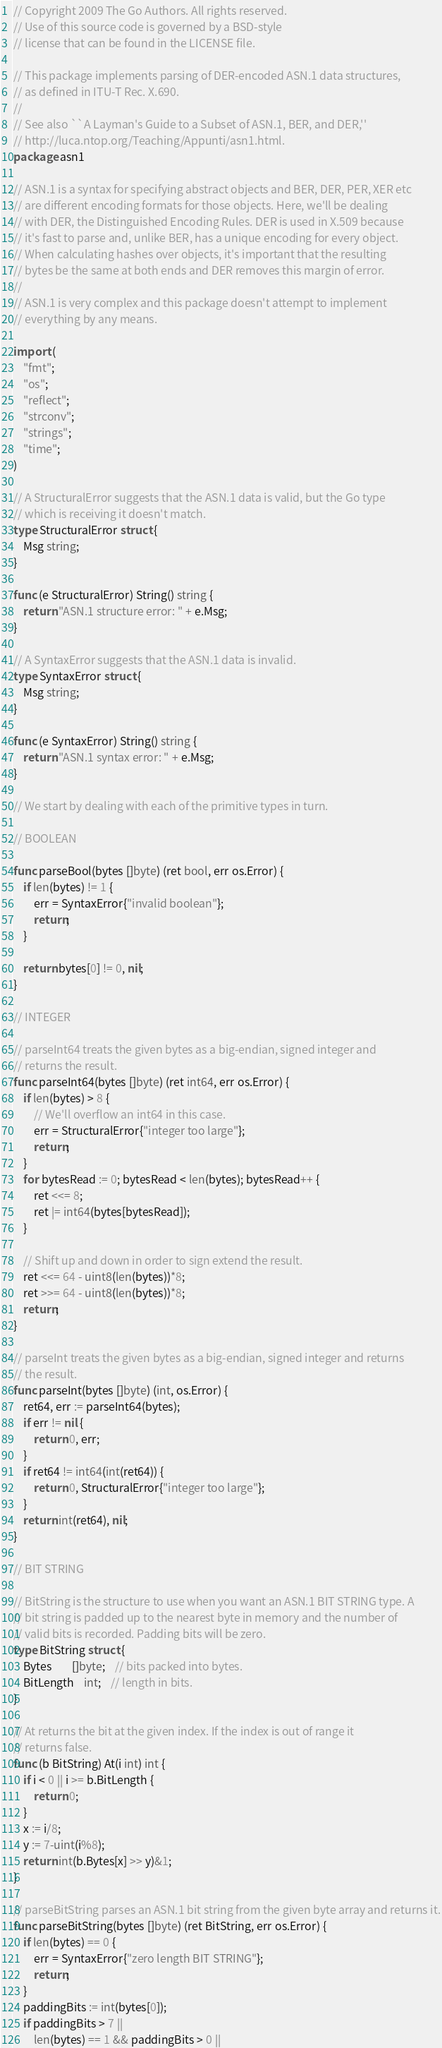Convert code to text. <code><loc_0><loc_0><loc_500><loc_500><_Go_>// Copyright 2009 The Go Authors. All rights reserved.
// Use of this source code is governed by a BSD-style
// license that can be found in the LICENSE file.

// This package implements parsing of DER-encoded ASN.1 data structures,
// as defined in ITU-T Rec. X.690.
//
// See also ``A Layman's Guide to a Subset of ASN.1, BER, and DER,''
// http://luca.ntop.org/Teaching/Appunti/asn1.html.
package asn1

// ASN.1 is a syntax for specifying abstract objects and BER, DER, PER, XER etc
// are different encoding formats for those objects. Here, we'll be dealing
// with DER, the Distinguished Encoding Rules. DER is used in X.509 because
// it's fast to parse and, unlike BER, has a unique encoding for every object.
// When calculating hashes over objects, it's important that the resulting
// bytes be the same at both ends and DER removes this margin of error.
//
// ASN.1 is very complex and this package doesn't attempt to implement
// everything by any means.

import (
	"fmt";
	"os";
	"reflect";
	"strconv";
	"strings";
	"time";
)

// A StructuralError suggests that the ASN.1 data is valid, but the Go type
// which is receiving it doesn't match.
type StructuralError struct {
	Msg string;
}

func (e StructuralError) String() string {
	return "ASN.1 structure error: " + e.Msg;
}

// A SyntaxError suggests that the ASN.1 data is invalid.
type SyntaxError struct {
	Msg string;
}

func (e SyntaxError) String() string {
	return "ASN.1 syntax error: " + e.Msg;
}

// We start by dealing with each of the primitive types in turn.

// BOOLEAN

func parseBool(bytes []byte) (ret bool, err os.Error) {
	if len(bytes) != 1 {
		err = SyntaxError{"invalid boolean"};
		return;
	}

	return bytes[0] != 0, nil;
}

// INTEGER

// parseInt64 treats the given bytes as a big-endian, signed integer and
// returns the result.
func parseInt64(bytes []byte) (ret int64, err os.Error) {
	if len(bytes) > 8 {
		// We'll overflow an int64 in this case.
		err = StructuralError{"integer too large"};
		return;
	}
	for bytesRead := 0; bytesRead < len(bytes); bytesRead++ {
		ret <<= 8;
		ret |= int64(bytes[bytesRead]);
	}

	// Shift up and down in order to sign extend the result.
	ret <<= 64 - uint8(len(bytes))*8;
	ret >>= 64 - uint8(len(bytes))*8;
	return;
}

// parseInt treats the given bytes as a big-endian, signed integer and returns
// the result.
func parseInt(bytes []byte) (int, os.Error) {
	ret64, err := parseInt64(bytes);
	if err != nil {
		return 0, err;
	}
	if ret64 != int64(int(ret64)) {
		return 0, StructuralError{"integer too large"};
	}
	return int(ret64), nil;
}

// BIT STRING

// BitString is the structure to use when you want an ASN.1 BIT STRING type. A
// bit string is padded up to the nearest byte in memory and the number of
// valid bits is recorded. Padding bits will be zero.
type BitString struct {
	Bytes		[]byte;	// bits packed into bytes.
	BitLength	int;	// length in bits.
}

// At returns the bit at the given index. If the index is out of range it
// returns false.
func (b BitString) At(i int) int {
	if i < 0 || i >= b.BitLength {
		return 0;
	}
	x := i/8;
	y := 7-uint(i%8);
	return int(b.Bytes[x] >> y)&1;
}

// parseBitString parses an ASN.1 bit string from the given byte array and returns it.
func parseBitString(bytes []byte) (ret BitString, err os.Error) {
	if len(bytes) == 0 {
		err = SyntaxError{"zero length BIT STRING"};
		return;
	}
	paddingBits := int(bytes[0]);
	if paddingBits > 7 ||
		len(bytes) == 1 && paddingBits > 0 ||</code> 